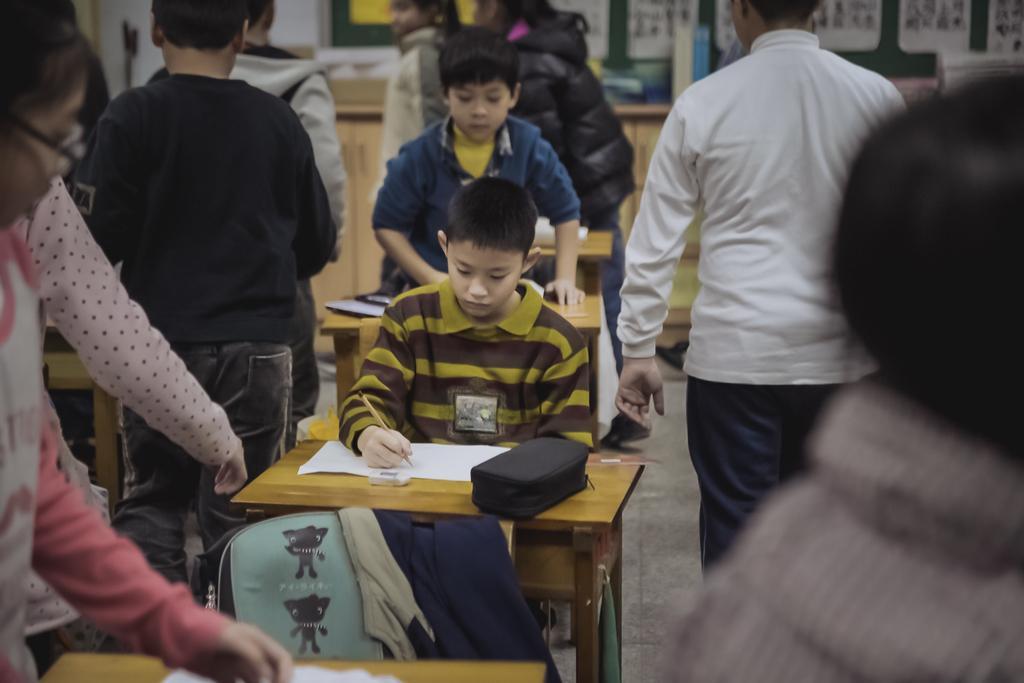Could you give a brief overview of what you see in this image? In this image there is a boy sitting in a chair near the table and writing something in the paper, there is a pouch , and eraser in the background there are group of people standing , another group of people standing , papers stick to the board and a cupboard. 